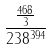Convert formula to latex. <formula><loc_0><loc_0><loc_500><loc_500>\frac { \frac { 4 6 8 } { 3 } } { 2 3 8 ^ { 3 9 4 } }</formula> 